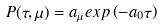<formula> <loc_0><loc_0><loc_500><loc_500>P ( \tau , \mu ) = a _ { \mu } e x p \left ( - a _ { 0 } \tau \right )</formula> 